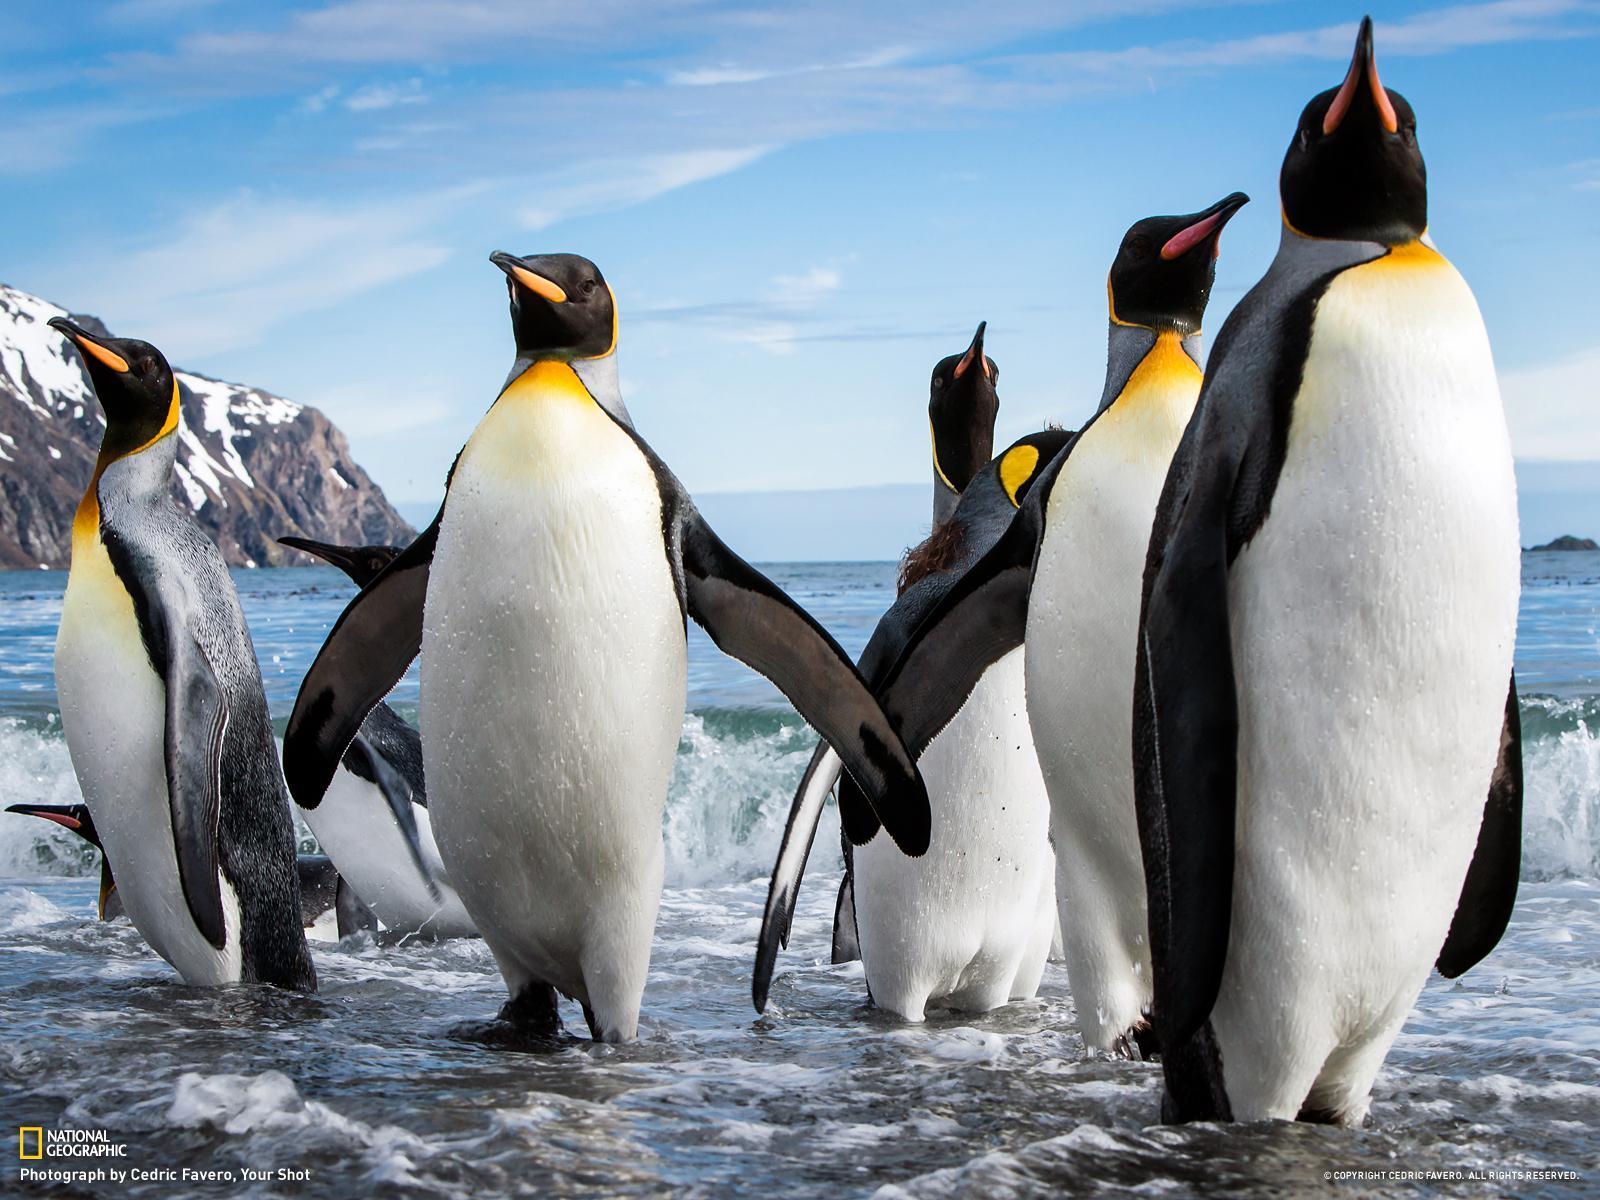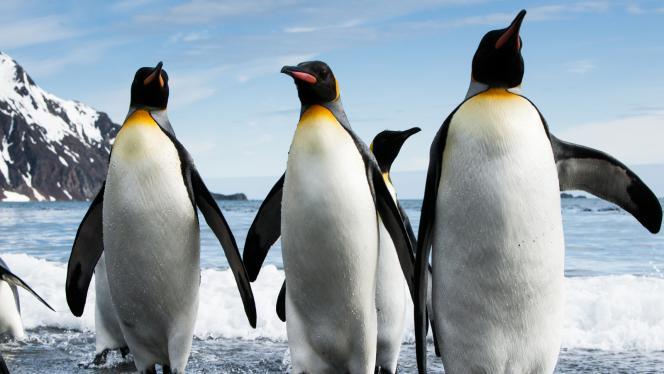The first image is the image on the left, the second image is the image on the right. Considering the images on both sides, is "There is at least one brown furry penguin." valid? Answer yes or no. No. The first image is the image on the left, the second image is the image on the right. Given the left and right images, does the statement "An image includes multiple penguins with fuzzy brown feathers, along with at least one black and white penguin." hold true? Answer yes or no. No. The first image is the image on the left, the second image is the image on the right. Evaluate the accuracy of this statement regarding the images: "A penguin in the foreground is at least partly covered in brown fuzzy feathers.". Is it true? Answer yes or no. No. 